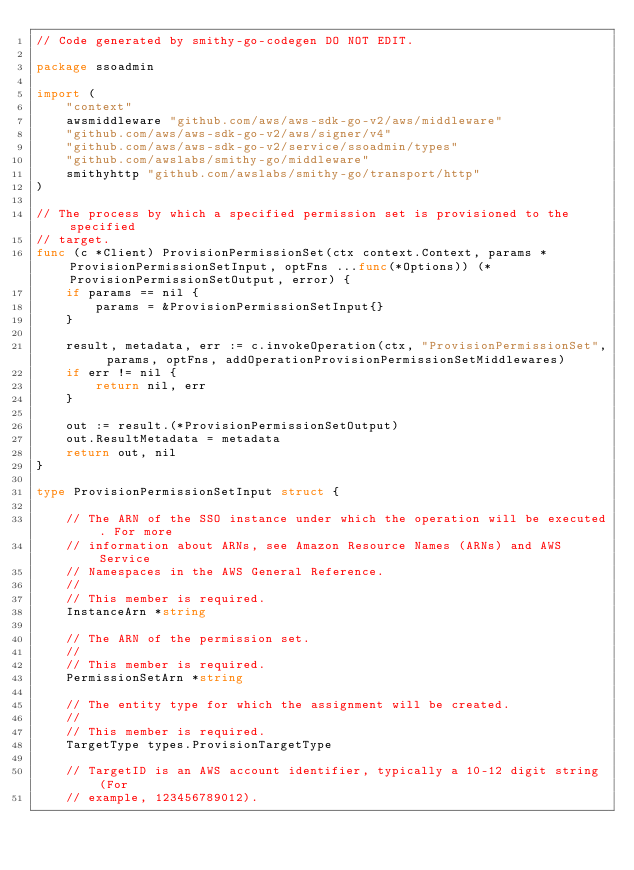Convert code to text. <code><loc_0><loc_0><loc_500><loc_500><_Go_>// Code generated by smithy-go-codegen DO NOT EDIT.

package ssoadmin

import (
	"context"
	awsmiddleware "github.com/aws/aws-sdk-go-v2/aws/middleware"
	"github.com/aws/aws-sdk-go-v2/aws/signer/v4"
	"github.com/aws/aws-sdk-go-v2/service/ssoadmin/types"
	"github.com/awslabs/smithy-go/middleware"
	smithyhttp "github.com/awslabs/smithy-go/transport/http"
)

// The process by which a specified permission set is provisioned to the specified
// target.
func (c *Client) ProvisionPermissionSet(ctx context.Context, params *ProvisionPermissionSetInput, optFns ...func(*Options)) (*ProvisionPermissionSetOutput, error) {
	if params == nil {
		params = &ProvisionPermissionSetInput{}
	}

	result, metadata, err := c.invokeOperation(ctx, "ProvisionPermissionSet", params, optFns, addOperationProvisionPermissionSetMiddlewares)
	if err != nil {
		return nil, err
	}

	out := result.(*ProvisionPermissionSetOutput)
	out.ResultMetadata = metadata
	return out, nil
}

type ProvisionPermissionSetInput struct {

	// The ARN of the SSO instance under which the operation will be executed. For more
	// information about ARNs, see Amazon Resource Names (ARNs) and AWS Service
	// Namespaces in the AWS General Reference.
	//
	// This member is required.
	InstanceArn *string

	// The ARN of the permission set.
	//
	// This member is required.
	PermissionSetArn *string

	// The entity type for which the assignment will be created.
	//
	// This member is required.
	TargetType types.ProvisionTargetType

	// TargetID is an AWS account identifier, typically a 10-12 digit string (For
	// example, 123456789012).</code> 